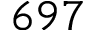Convert formula to latex. <formula><loc_0><loc_0><loc_500><loc_500>6 9 7</formula> 